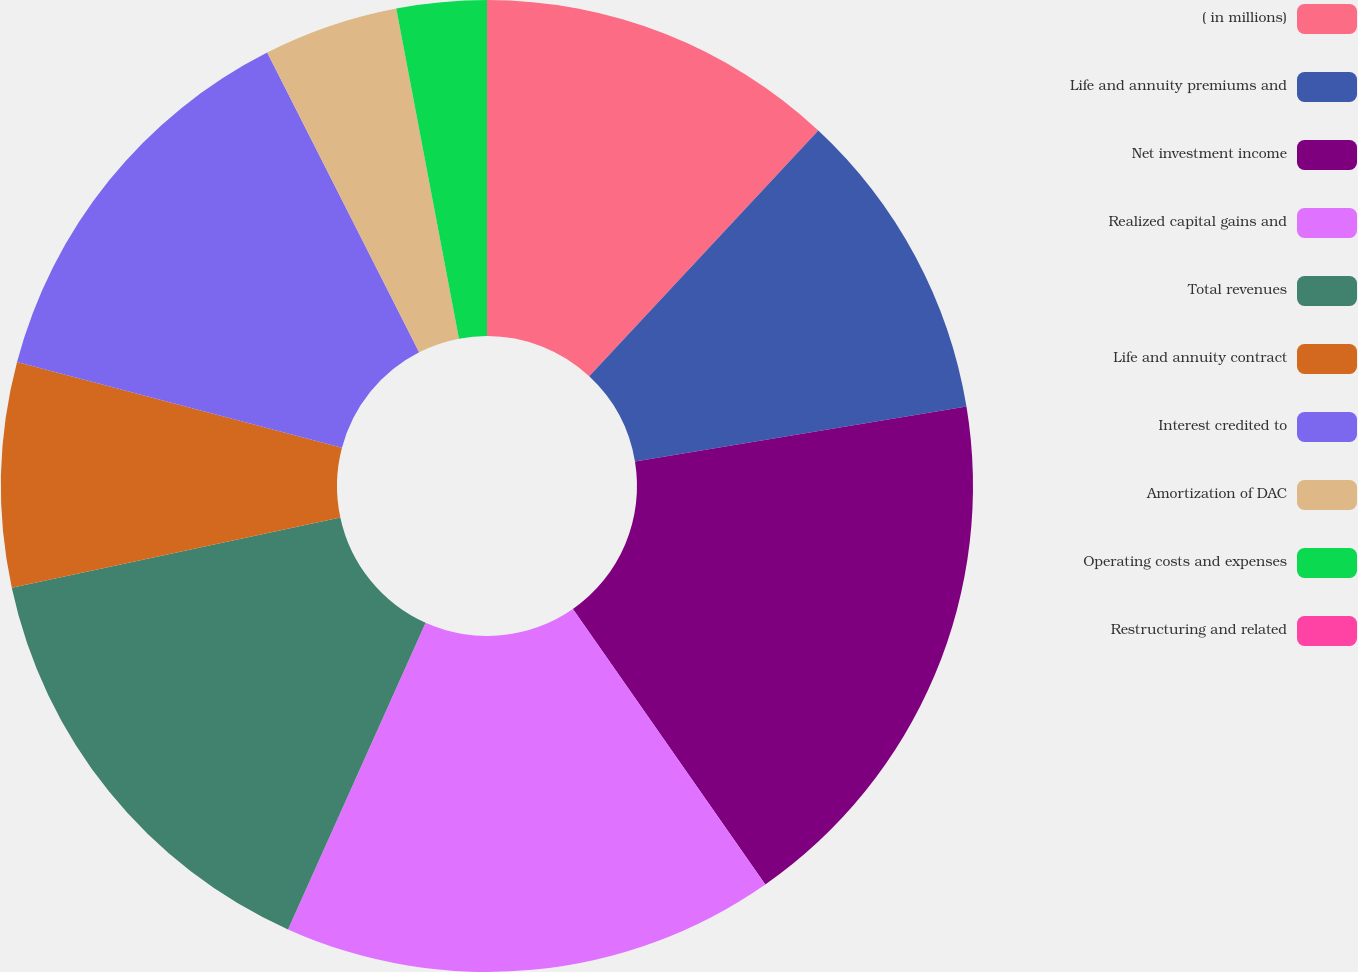Convert chart. <chart><loc_0><loc_0><loc_500><loc_500><pie_chart><fcel>( in millions)<fcel>Life and annuity premiums and<fcel>Net investment income<fcel>Realized capital gains and<fcel>Total revenues<fcel>Life and annuity contract<fcel>Interest credited to<fcel>Amortization of DAC<fcel>Operating costs and expenses<fcel>Restructuring and related<nl><fcel>11.94%<fcel>10.45%<fcel>17.91%<fcel>16.42%<fcel>14.93%<fcel>7.46%<fcel>13.43%<fcel>4.48%<fcel>2.99%<fcel>0.0%<nl></chart> 